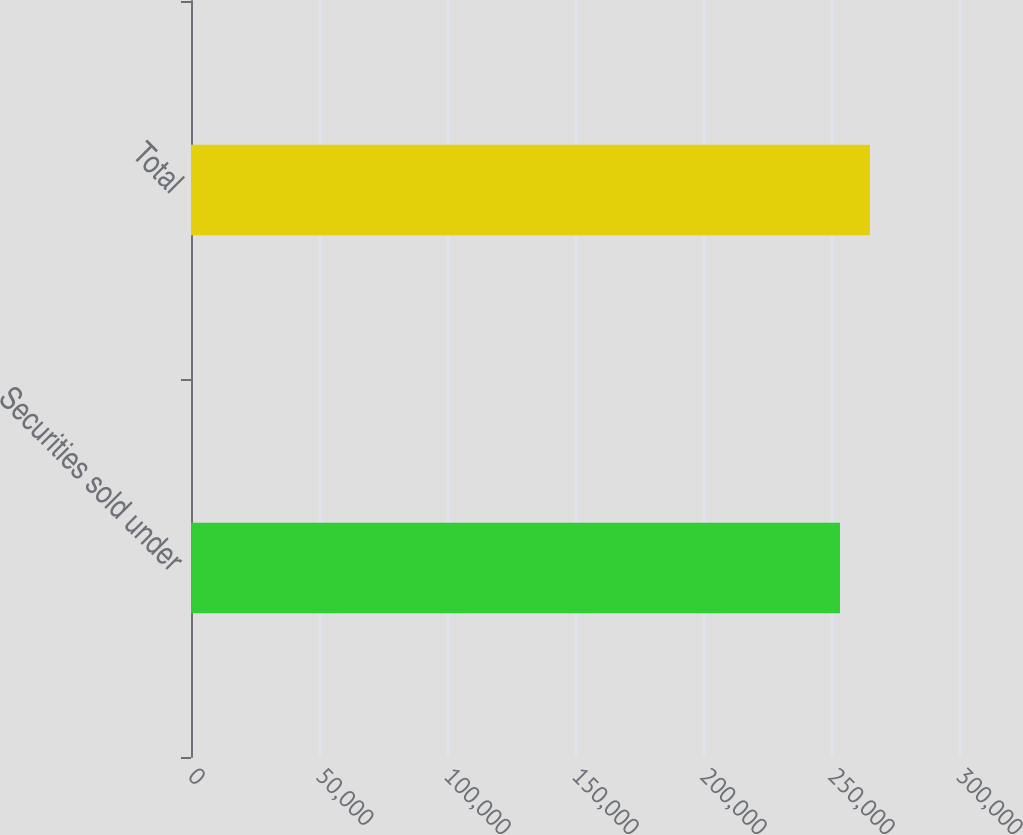Convert chart to OTSL. <chart><loc_0><loc_0><loc_500><loc_500><bar_chart><fcel>Securities sold under<fcel>Total<nl><fcel>253514<fcel>265192<nl></chart> 